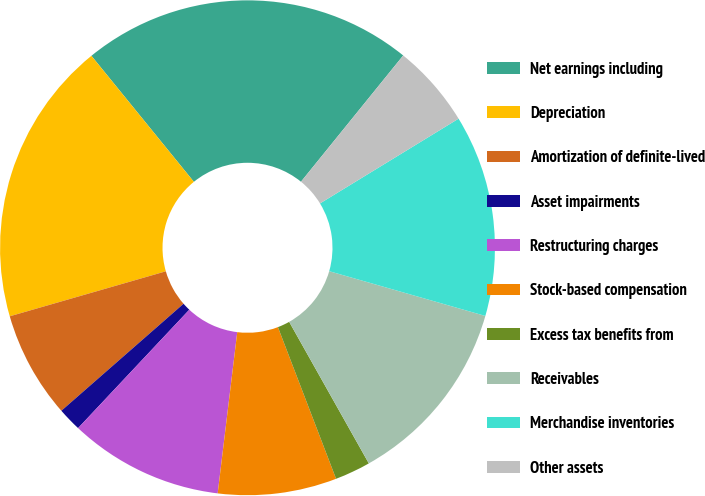<chart> <loc_0><loc_0><loc_500><loc_500><pie_chart><fcel>Net earnings including<fcel>Depreciation<fcel>Amortization of definite-lived<fcel>Asset impairments<fcel>Restructuring charges<fcel>Stock-based compensation<fcel>Excess tax benefits from<fcel>Receivables<fcel>Merchandise inventories<fcel>Other assets<nl><fcel>21.7%<fcel>18.6%<fcel>6.98%<fcel>1.55%<fcel>10.08%<fcel>7.75%<fcel>2.33%<fcel>12.4%<fcel>13.18%<fcel>5.43%<nl></chart> 